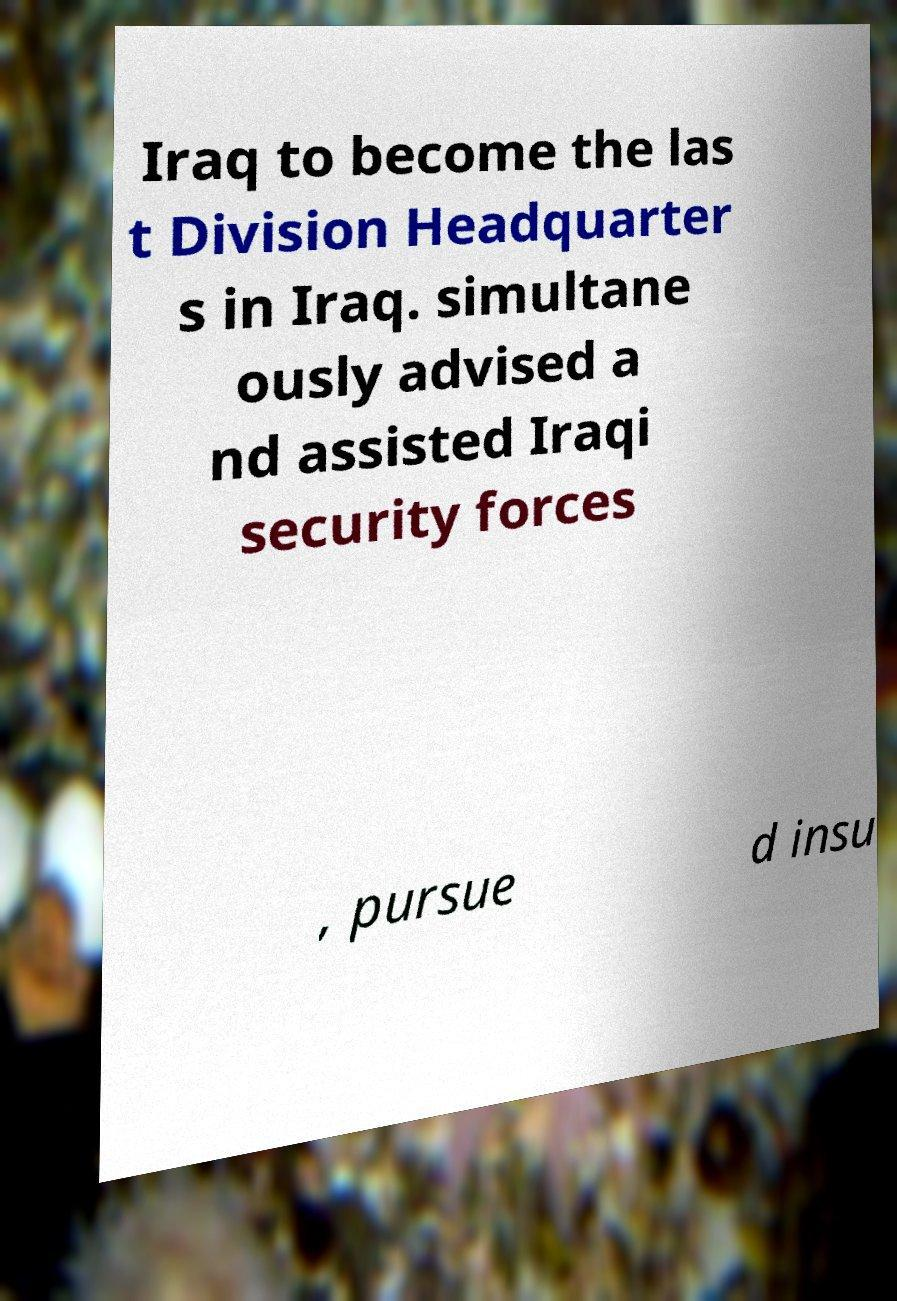What messages or text are displayed in this image? I need them in a readable, typed format. Iraq to become the las t Division Headquarter s in Iraq. simultane ously advised a nd assisted Iraqi security forces , pursue d insu 